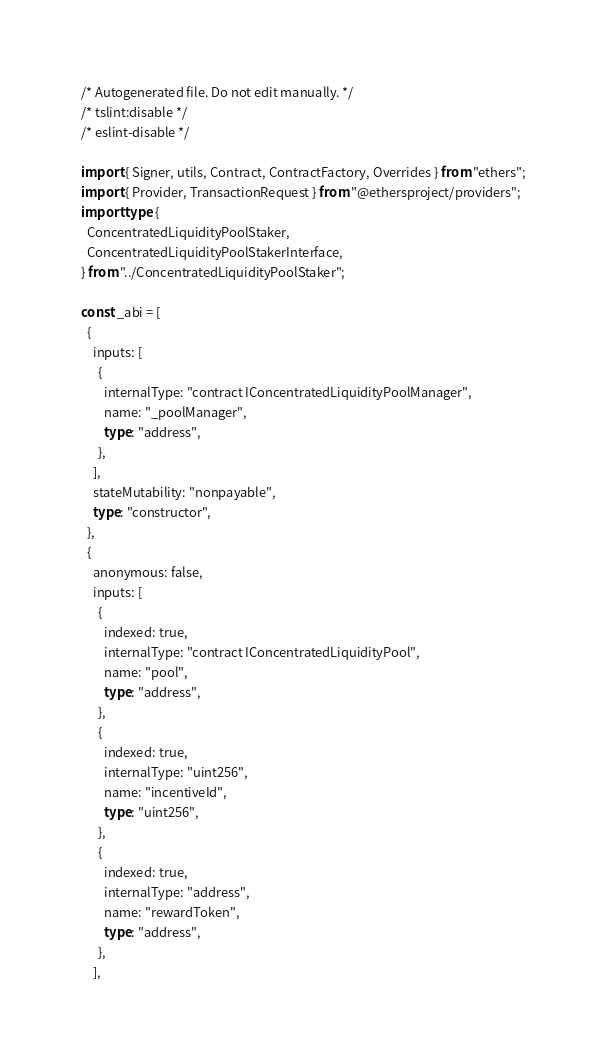Convert code to text. <code><loc_0><loc_0><loc_500><loc_500><_TypeScript_>/* Autogenerated file. Do not edit manually. */
/* tslint:disable */
/* eslint-disable */

import { Signer, utils, Contract, ContractFactory, Overrides } from "ethers";
import { Provider, TransactionRequest } from "@ethersproject/providers";
import type {
  ConcentratedLiquidityPoolStaker,
  ConcentratedLiquidityPoolStakerInterface,
} from "../ConcentratedLiquidityPoolStaker";

const _abi = [
  {
    inputs: [
      {
        internalType: "contract IConcentratedLiquidityPoolManager",
        name: "_poolManager",
        type: "address",
      },
    ],
    stateMutability: "nonpayable",
    type: "constructor",
  },
  {
    anonymous: false,
    inputs: [
      {
        indexed: true,
        internalType: "contract IConcentratedLiquidityPool",
        name: "pool",
        type: "address",
      },
      {
        indexed: true,
        internalType: "uint256",
        name: "incentiveId",
        type: "uint256",
      },
      {
        indexed: true,
        internalType: "address",
        name: "rewardToken",
        type: "address",
      },
    ],</code> 